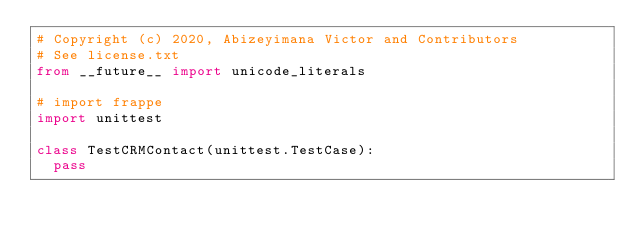<code> <loc_0><loc_0><loc_500><loc_500><_Python_># Copyright (c) 2020, Abizeyimana Victor and Contributors
# See license.txt
from __future__ import unicode_literals

# import frappe
import unittest

class TestCRMContact(unittest.TestCase):
	pass
</code> 